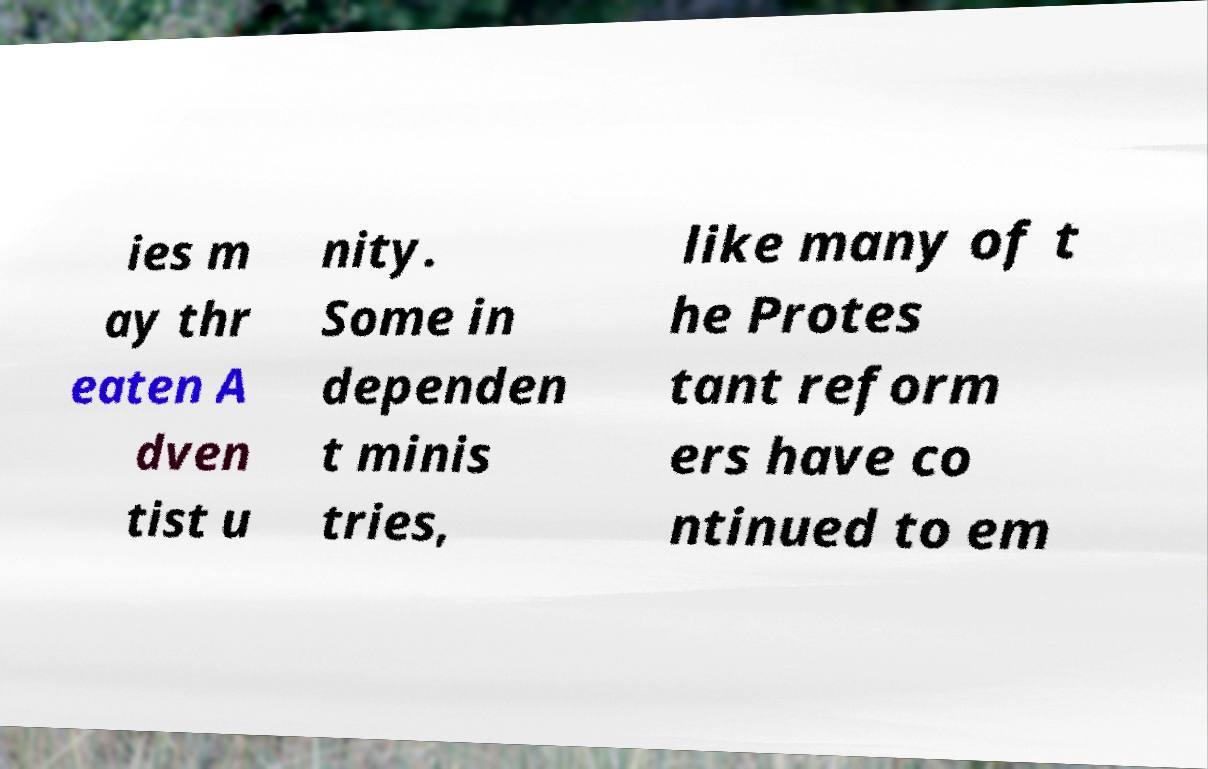What messages or text are displayed in this image? I need them in a readable, typed format. ies m ay thr eaten A dven tist u nity. Some in dependen t minis tries, like many of t he Protes tant reform ers have co ntinued to em 